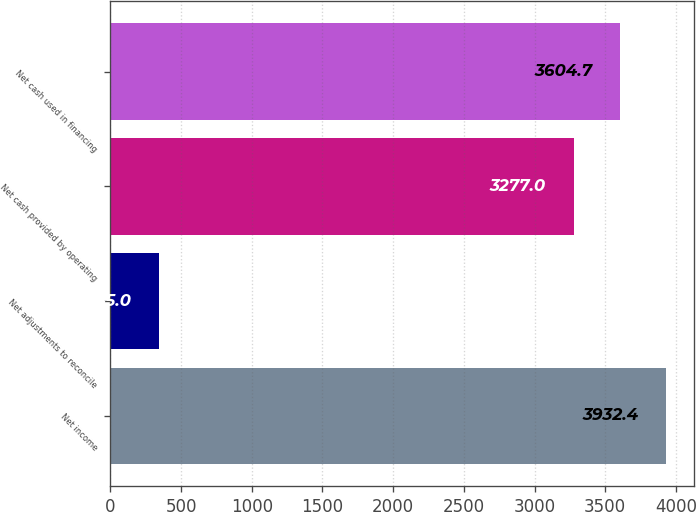<chart> <loc_0><loc_0><loc_500><loc_500><bar_chart><fcel>Net income<fcel>Net adjustments to reconcile<fcel>Net cash provided by operating<fcel>Net cash used in financing<nl><fcel>3932.4<fcel>345<fcel>3277<fcel>3604.7<nl></chart> 